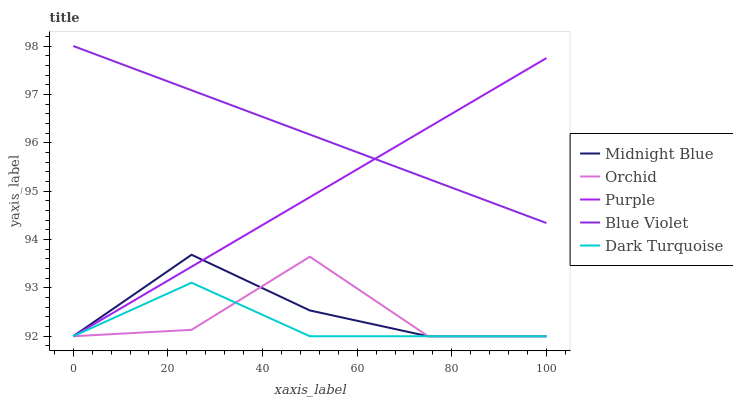Does Dark Turquoise have the minimum area under the curve?
Answer yes or no. Yes. Does Midnight Blue have the minimum area under the curve?
Answer yes or no. No. Does Midnight Blue have the maximum area under the curve?
Answer yes or no. No. Is Purple the smoothest?
Answer yes or no. Yes. Is Orchid the roughest?
Answer yes or no. Yes. Is Dark Turquoise the smoothest?
Answer yes or no. No. Is Dark Turquoise the roughest?
Answer yes or no. No. Does Blue Violet have the lowest value?
Answer yes or no. No. Does Midnight Blue have the highest value?
Answer yes or no. No. Is Dark Turquoise less than Blue Violet?
Answer yes or no. Yes. Is Blue Violet greater than Orchid?
Answer yes or no. Yes. Does Dark Turquoise intersect Blue Violet?
Answer yes or no. No. 